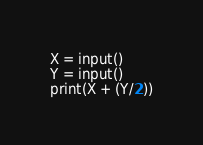<code> <loc_0><loc_0><loc_500><loc_500><_Python_>X = input()
Y = input()
print(X + (Y/2))</code> 